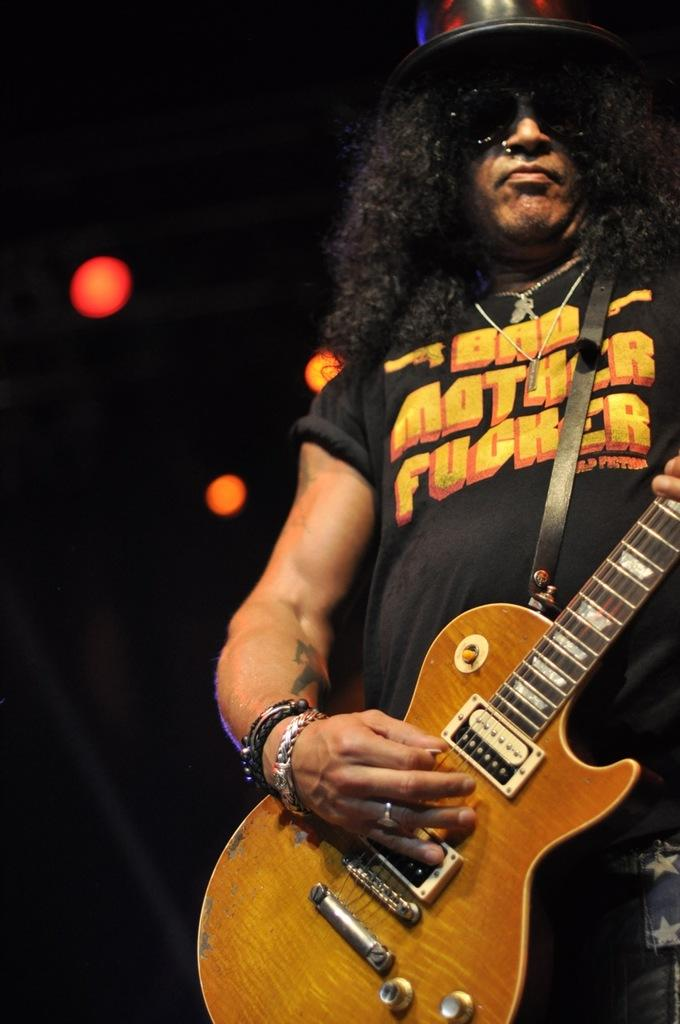What is the main subject of the image? There is a person in the image. What is the person holding in the image? The person is holding a guitar. Can you describe the person's attire in the image? The person is wearing a black hat. What type of stamp can be seen on the person's forehead in the image? There is no stamp present on the person's forehead in the image. Can you describe the hall where the person is playing the guitar in the image? The image does not show a hall or any specific location where the person is playing the guitar. 